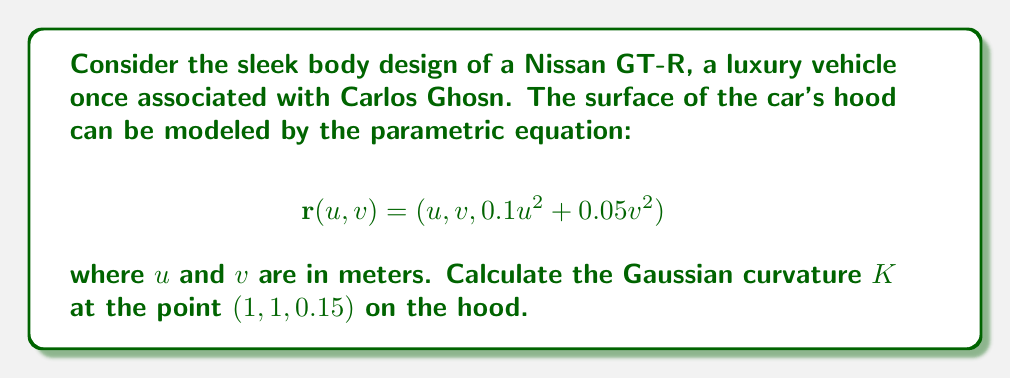Show me your answer to this math problem. To find the Gaussian curvature, we need to follow these steps:

1) First, calculate the first fundamental form coefficients:
   $$E = \mathbf{r}_u \cdot \mathbf{r}_u, \quad F = \mathbf{r}_u \cdot \mathbf{r}_v, \quad G = \mathbf{r}_v \cdot \mathbf{r}_v$$

2) Then, calculate the second fundamental form coefficients:
   $$L = \mathbf{n} \cdot \mathbf{r}_{uu}, \quad M = \mathbf{n} \cdot \mathbf{r}_{uv}, \quad N = \mathbf{n} \cdot \mathbf{r}_{vv}$$

   where $\mathbf{n}$ is the unit normal vector.

3) The Gaussian curvature is given by:
   $$K = \frac{LN - M^2}{EG - F^2}$$

Let's proceed step by step:

1) Calculate partial derivatives:
   $$\mathbf{r}_u = (1, 0, 0.2u)$$
   $$\mathbf{r}_v = (0, 1, 0.1v)$$
   $$\mathbf{r}_{uu} = (0, 0, 0.2)$$
   $$\mathbf{r}_{vv} = (0, 0, 0.1)$$
   $$\mathbf{r}_{uv} = (0, 0, 0)$$

2) Calculate first fundamental form coefficients:
   $$E = 1 + 0.04u^2 = 1.04$$
   $$F = 0.02uv = 0.02$$
   $$G = 1 + 0.01v^2 = 1.01$$

3) Calculate the unit normal vector:
   $$\mathbf{n} = \frac{\mathbf{r}_u \times \mathbf{r}_v}{|\mathbf{r}_u \times \mathbf{r}_v|} = \frac{(-0.2u, -0.1v, 1)}{\sqrt{1 + 0.04u^2 + 0.01v^2}}$$

4) Calculate second fundamental form coefficients:
   $$L = \frac{0.2}{\sqrt{1.05}} \approx 0.1952$$
   $$M = 0$$
   $$N = \frac{0.1}{\sqrt{1.05}} \approx 0.0976$$

5) Calculate Gaussian curvature:
   $$K = \frac{LN - M^2}{EG - F^2} = \frac{(0.1952)(0.0976) - 0^2}{(1.04)(1.01) - 0.02^2} \approx 0.0184$$

Therefore, the Gaussian curvature at the point (1, 1, 0.15) is approximately 0.0184 m^(-2).
Answer: $K \approx 0.0184$ m^(-2) 